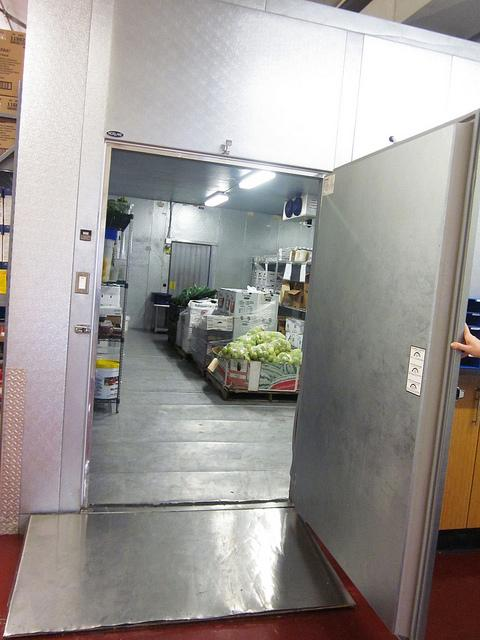What does this door lead to?

Choices:
A) dining area
B) walkin cooler
C) exit
D) bathroom walkin cooler 